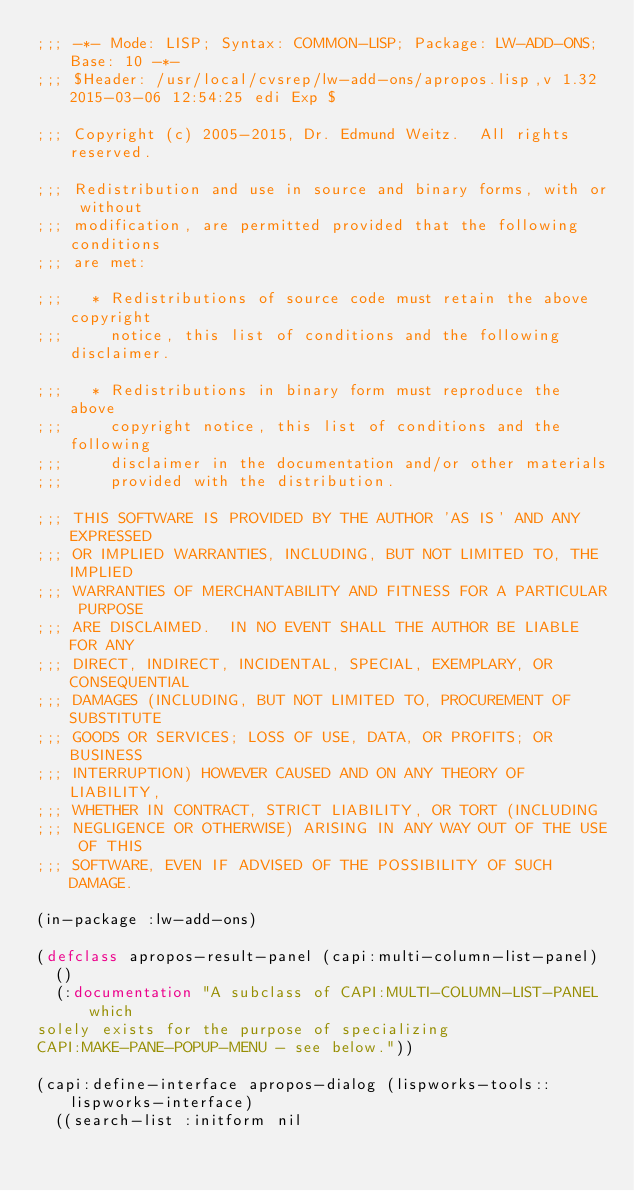Convert code to text. <code><loc_0><loc_0><loc_500><loc_500><_Lisp_>;;; -*- Mode: LISP; Syntax: COMMON-LISP; Package: LW-ADD-ONS; Base: 10 -*-
;;; $Header: /usr/local/cvsrep/lw-add-ons/apropos.lisp,v 1.32 2015-03-06 12:54:25 edi Exp $

;;; Copyright (c) 2005-2015, Dr. Edmund Weitz.  All rights reserved. 

;;; Redistribution and use in source and binary forms, with or without
;;; modification, are permitted provided that the following conditions
;;; are met:

;;;   * Redistributions of source code must retain the above copyright
;;;     notice, this list of conditions and the following disclaimer.

;;;   * Redistributions in binary form must reproduce the above
;;;     copyright notice, this list of conditions and the following
;;;     disclaimer in the documentation and/or other materials
;;;     provided with the distribution.

;;; THIS SOFTWARE IS PROVIDED BY THE AUTHOR 'AS IS' AND ANY EXPRESSED
;;; OR IMPLIED WARRANTIES, INCLUDING, BUT NOT LIMITED TO, THE IMPLIED
;;; WARRANTIES OF MERCHANTABILITY AND FITNESS FOR A PARTICULAR PURPOSE
;;; ARE DISCLAIMED.  IN NO EVENT SHALL THE AUTHOR BE LIABLE FOR ANY
;;; DIRECT, INDIRECT, INCIDENTAL, SPECIAL, EXEMPLARY, OR CONSEQUENTIAL
;;; DAMAGES (INCLUDING, BUT NOT LIMITED TO, PROCUREMENT OF SUBSTITUTE
;;; GOODS OR SERVICES; LOSS OF USE, DATA, OR PROFITS; OR BUSINESS
;;; INTERRUPTION) HOWEVER CAUSED AND ON ANY THEORY OF LIABILITY,
;;; WHETHER IN CONTRACT, STRICT LIABILITY, OR TORT (INCLUDING
;;; NEGLIGENCE OR OTHERWISE) ARISING IN ANY WAY OUT OF THE USE OF THIS
;;; SOFTWARE, EVEN IF ADVISED OF THE POSSIBILITY OF SUCH DAMAGE.

(in-package :lw-add-ons)

(defclass apropos-result-panel (capi:multi-column-list-panel)
  ()
  (:documentation "A subclass of CAPI:MULTI-COLUMN-LIST-PANEL which
solely exists for the purpose of specializing
CAPI:MAKE-PANE-POPUP-MENU - see below."))

(capi:define-interface apropos-dialog (lispworks-tools::lispworks-interface)
  ((search-list :initform nil</code> 